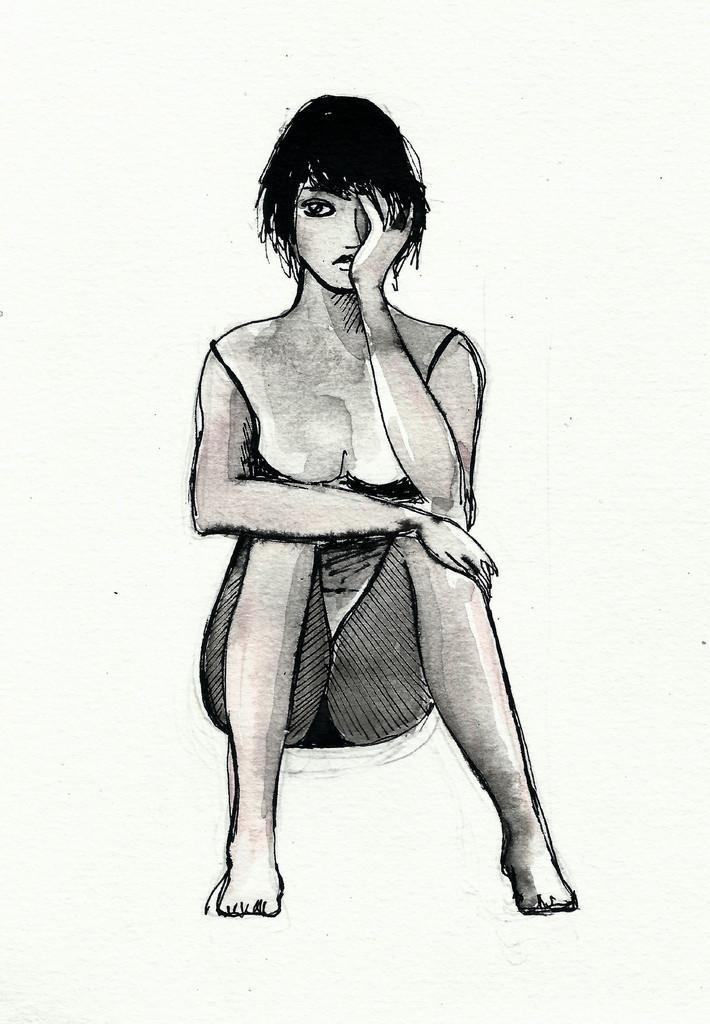What is depicted in the image? There is a sketch of a person sitting in the image. What color is the background of the image? The background of the image is white. What type of silver roof can be seen above the person in the image? There is no roof, silver or otherwise, present in the image. The image only contains a sketch of a person sitting on a white background. 